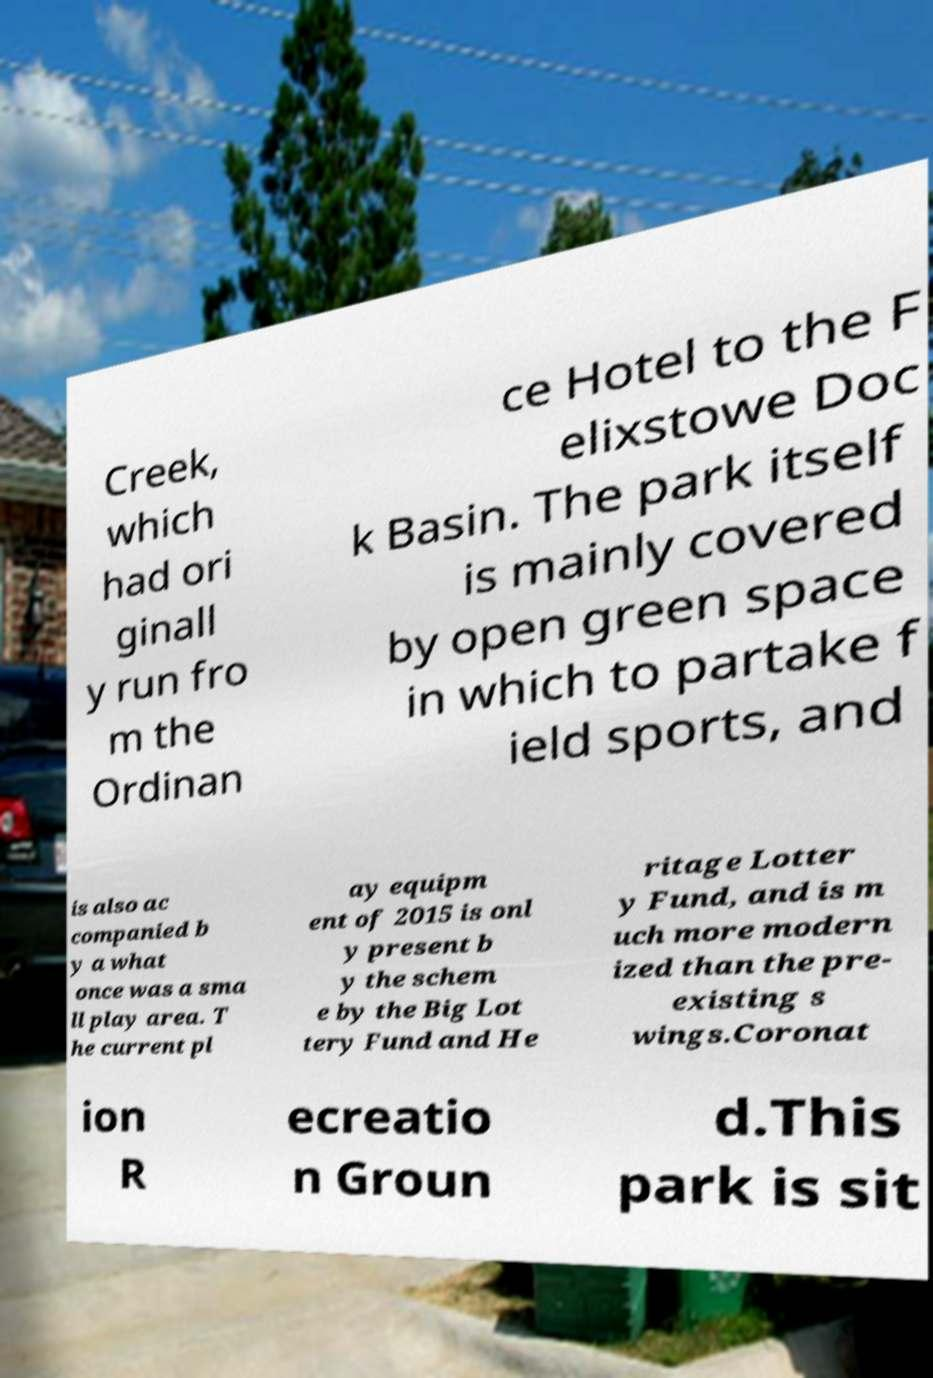There's text embedded in this image that I need extracted. Can you transcribe it verbatim? Creek, which had ori ginall y run fro m the Ordinan ce Hotel to the F elixstowe Doc k Basin. The park itself is mainly covered by open green space in which to partake f ield sports, and is also ac companied b y a what once was a sma ll play area. T he current pl ay equipm ent of 2015 is onl y present b y the schem e by the Big Lot tery Fund and He ritage Lotter y Fund, and is m uch more modern ized than the pre- existing s wings.Coronat ion R ecreatio n Groun d.This park is sit 